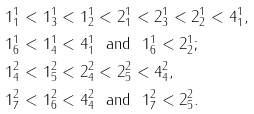<formula> <loc_0><loc_0><loc_500><loc_500>& 1 ^ { 1 } _ { 1 } < 1 ^ { 1 } _ { 3 } < 1 ^ { 1 } _ { 2 } < 2 ^ { 1 } _ { 1 } < 2 ^ { 1 } _ { 3 } < 2 ^ { 1 } _ { 2 } < 4 ^ { 1 } _ { 1 } , \\ & 1 ^ { 1 } _ { 6 } < 1 ^ { 1 } _ { 4 } < 4 ^ { 1 } _ { 1 } \ \text { and } \ 1 ^ { 1 } _ { 6 } < 2 ^ { 1 } _ { 2 } ; \\ & 1 ^ { 2 } _ { 4 } < 1 ^ { 2 } _ { 5 } < 2 ^ { 2 } _ { 4 } < 2 ^ { 2 } _ { 5 } < 4 ^ { 2 } _ { 4 } , \\ & 1 ^ { 2 } _ { 7 } < 1 ^ { 2 } _ { 6 } < 4 ^ { 2 } _ { 4 } \ \text { and } \ 1 ^ { 2 } _ { 7 } < 2 ^ { 2 } _ { 5 } .</formula> 